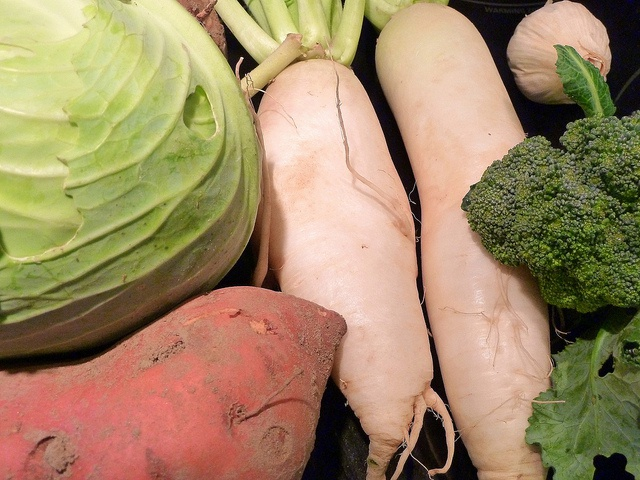Describe the objects in this image and their specific colors. I can see a broccoli in khaki, darkgreen, black, and olive tones in this image. 